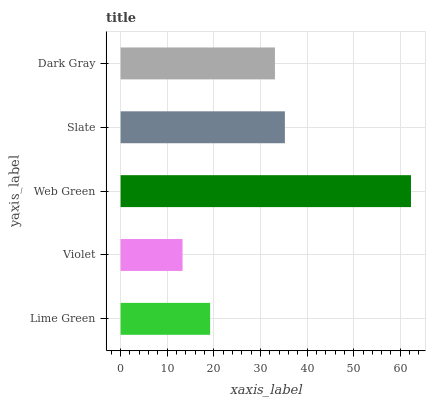Is Violet the minimum?
Answer yes or no. Yes. Is Web Green the maximum?
Answer yes or no. Yes. Is Web Green the minimum?
Answer yes or no. No. Is Violet the maximum?
Answer yes or no. No. Is Web Green greater than Violet?
Answer yes or no. Yes. Is Violet less than Web Green?
Answer yes or no. Yes. Is Violet greater than Web Green?
Answer yes or no. No. Is Web Green less than Violet?
Answer yes or no. No. Is Dark Gray the high median?
Answer yes or no. Yes. Is Dark Gray the low median?
Answer yes or no. Yes. Is Violet the high median?
Answer yes or no. No. Is Lime Green the low median?
Answer yes or no. No. 